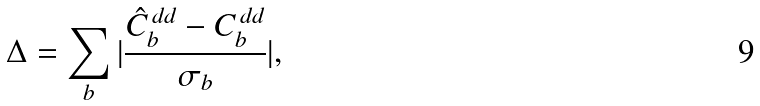Convert formula to latex. <formula><loc_0><loc_0><loc_500><loc_500>\Delta = \sum _ { b } | \frac { \hat { C } _ { b } ^ { \, d d } - C _ { b } ^ { \, d d } } { \sigma _ { b } } | ,</formula> 